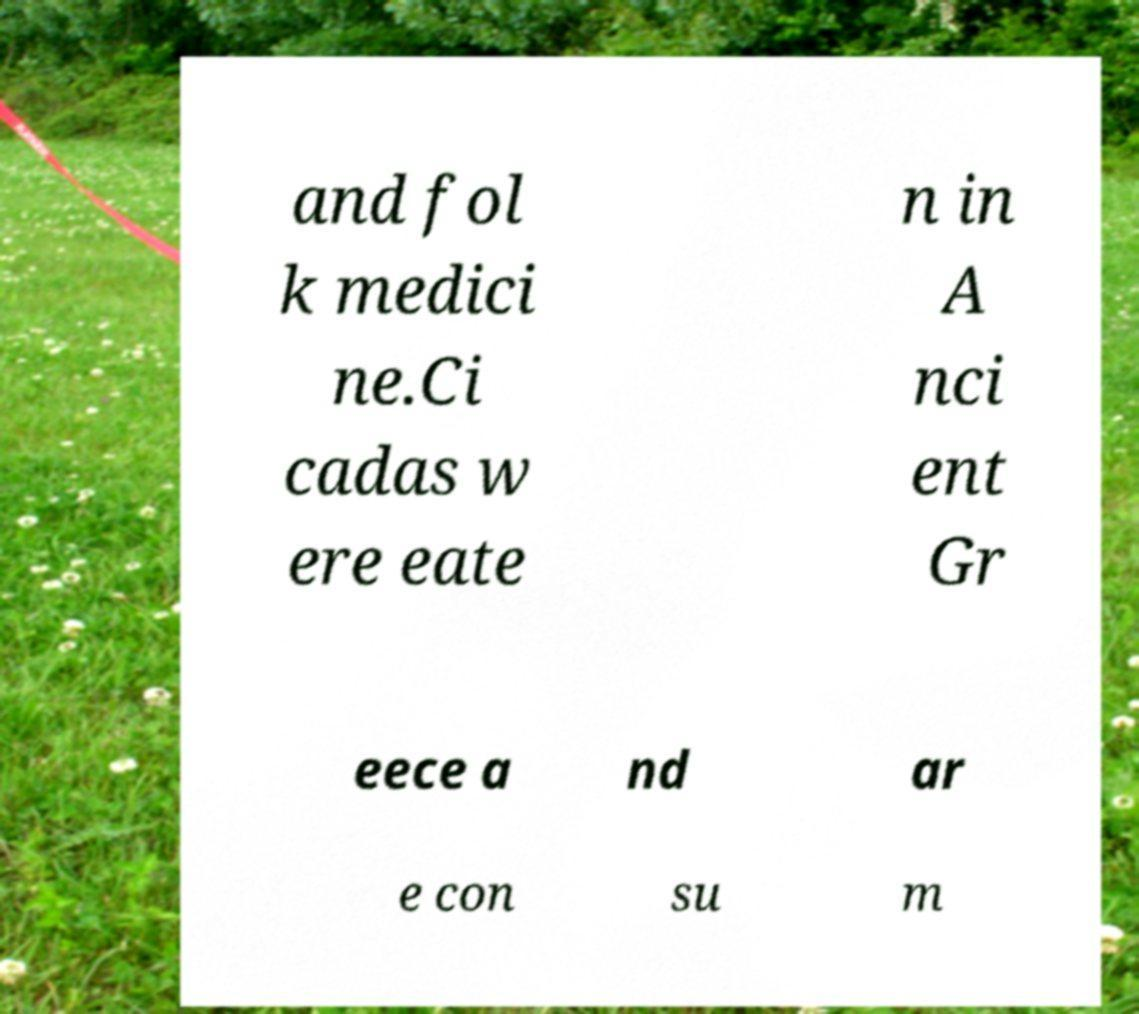Could you extract and type out the text from this image? and fol k medici ne.Ci cadas w ere eate n in A nci ent Gr eece a nd ar e con su m 